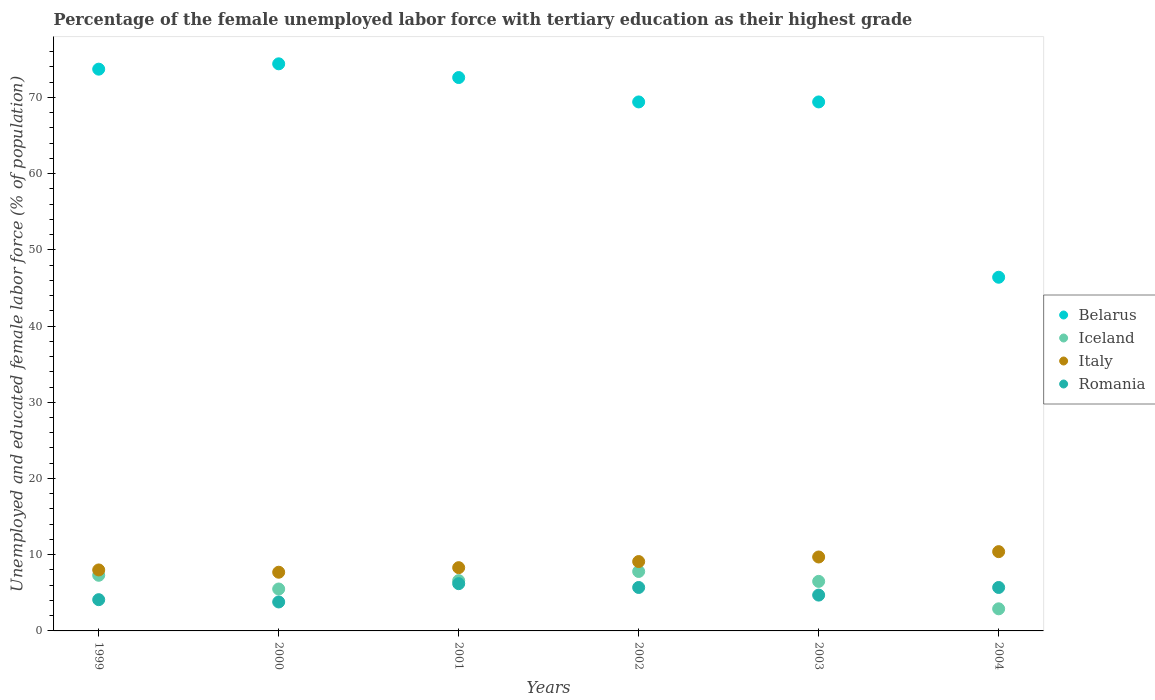Is the number of dotlines equal to the number of legend labels?
Offer a terse response. Yes. What is the percentage of the unemployed female labor force with tertiary education in Italy in 2004?
Provide a succinct answer. 10.4. Across all years, what is the maximum percentage of the unemployed female labor force with tertiary education in Iceland?
Offer a very short reply. 7.8. Across all years, what is the minimum percentage of the unemployed female labor force with tertiary education in Italy?
Your answer should be compact. 7.7. In which year was the percentage of the unemployed female labor force with tertiary education in Romania maximum?
Provide a short and direct response. 2001. What is the total percentage of the unemployed female labor force with tertiary education in Iceland in the graph?
Give a very brief answer. 36.6. What is the difference between the percentage of the unemployed female labor force with tertiary education in Italy in 1999 and that in 2003?
Offer a terse response. -1.7. What is the difference between the percentage of the unemployed female labor force with tertiary education in Romania in 2004 and the percentage of the unemployed female labor force with tertiary education in Belarus in 2002?
Provide a succinct answer. -63.7. What is the average percentage of the unemployed female labor force with tertiary education in Romania per year?
Give a very brief answer. 5.03. In the year 2004, what is the difference between the percentage of the unemployed female labor force with tertiary education in Belarus and percentage of the unemployed female labor force with tertiary education in Romania?
Your response must be concise. 40.7. In how many years, is the percentage of the unemployed female labor force with tertiary education in Italy greater than 2 %?
Offer a very short reply. 6. What is the ratio of the percentage of the unemployed female labor force with tertiary education in Belarus in 2001 to that in 2002?
Provide a succinct answer. 1.05. Is the percentage of the unemployed female labor force with tertiary education in Romania in 2002 less than that in 2004?
Provide a succinct answer. No. What is the difference between the highest and the second highest percentage of the unemployed female labor force with tertiary education in Belarus?
Provide a succinct answer. 0.7. What is the difference between the highest and the lowest percentage of the unemployed female labor force with tertiary education in Italy?
Make the answer very short. 2.7. Is it the case that in every year, the sum of the percentage of the unemployed female labor force with tertiary education in Italy and percentage of the unemployed female labor force with tertiary education in Belarus  is greater than the sum of percentage of the unemployed female labor force with tertiary education in Iceland and percentage of the unemployed female labor force with tertiary education in Romania?
Give a very brief answer. Yes. Is the percentage of the unemployed female labor force with tertiary education in Italy strictly greater than the percentage of the unemployed female labor force with tertiary education in Belarus over the years?
Your answer should be very brief. No. How many years are there in the graph?
Give a very brief answer. 6. Are the values on the major ticks of Y-axis written in scientific E-notation?
Keep it short and to the point. No. Does the graph contain any zero values?
Your answer should be very brief. No. Does the graph contain grids?
Ensure brevity in your answer.  No. What is the title of the graph?
Provide a succinct answer. Percentage of the female unemployed labor force with tertiary education as their highest grade. Does "Lithuania" appear as one of the legend labels in the graph?
Your answer should be very brief. No. What is the label or title of the Y-axis?
Ensure brevity in your answer.  Unemployed and educated female labor force (% of population). What is the Unemployed and educated female labor force (% of population) in Belarus in 1999?
Keep it short and to the point. 73.7. What is the Unemployed and educated female labor force (% of population) of Iceland in 1999?
Ensure brevity in your answer.  7.3. What is the Unemployed and educated female labor force (% of population) in Italy in 1999?
Provide a short and direct response. 8. What is the Unemployed and educated female labor force (% of population) of Romania in 1999?
Your response must be concise. 4.1. What is the Unemployed and educated female labor force (% of population) in Belarus in 2000?
Make the answer very short. 74.4. What is the Unemployed and educated female labor force (% of population) in Iceland in 2000?
Your answer should be very brief. 5.5. What is the Unemployed and educated female labor force (% of population) in Italy in 2000?
Ensure brevity in your answer.  7.7. What is the Unemployed and educated female labor force (% of population) in Romania in 2000?
Your answer should be compact. 3.8. What is the Unemployed and educated female labor force (% of population) in Belarus in 2001?
Offer a very short reply. 72.6. What is the Unemployed and educated female labor force (% of population) of Iceland in 2001?
Ensure brevity in your answer.  6.6. What is the Unemployed and educated female labor force (% of population) in Italy in 2001?
Offer a very short reply. 8.3. What is the Unemployed and educated female labor force (% of population) in Romania in 2001?
Your answer should be very brief. 6.2. What is the Unemployed and educated female labor force (% of population) in Belarus in 2002?
Provide a succinct answer. 69.4. What is the Unemployed and educated female labor force (% of population) in Iceland in 2002?
Provide a succinct answer. 7.8. What is the Unemployed and educated female labor force (% of population) of Italy in 2002?
Offer a very short reply. 9.1. What is the Unemployed and educated female labor force (% of population) of Romania in 2002?
Provide a succinct answer. 5.7. What is the Unemployed and educated female labor force (% of population) of Belarus in 2003?
Give a very brief answer. 69.4. What is the Unemployed and educated female labor force (% of population) in Italy in 2003?
Keep it short and to the point. 9.7. What is the Unemployed and educated female labor force (% of population) of Romania in 2003?
Offer a very short reply. 4.7. What is the Unemployed and educated female labor force (% of population) in Belarus in 2004?
Offer a terse response. 46.4. What is the Unemployed and educated female labor force (% of population) in Iceland in 2004?
Give a very brief answer. 2.9. What is the Unemployed and educated female labor force (% of population) in Italy in 2004?
Provide a short and direct response. 10.4. What is the Unemployed and educated female labor force (% of population) in Romania in 2004?
Your answer should be very brief. 5.7. Across all years, what is the maximum Unemployed and educated female labor force (% of population) in Belarus?
Keep it short and to the point. 74.4. Across all years, what is the maximum Unemployed and educated female labor force (% of population) in Iceland?
Your answer should be very brief. 7.8. Across all years, what is the maximum Unemployed and educated female labor force (% of population) in Italy?
Your response must be concise. 10.4. Across all years, what is the maximum Unemployed and educated female labor force (% of population) in Romania?
Make the answer very short. 6.2. Across all years, what is the minimum Unemployed and educated female labor force (% of population) of Belarus?
Your answer should be compact. 46.4. Across all years, what is the minimum Unemployed and educated female labor force (% of population) of Iceland?
Keep it short and to the point. 2.9. Across all years, what is the minimum Unemployed and educated female labor force (% of population) of Italy?
Your answer should be very brief. 7.7. Across all years, what is the minimum Unemployed and educated female labor force (% of population) of Romania?
Your answer should be compact. 3.8. What is the total Unemployed and educated female labor force (% of population) in Belarus in the graph?
Provide a short and direct response. 405.9. What is the total Unemployed and educated female labor force (% of population) of Iceland in the graph?
Ensure brevity in your answer.  36.6. What is the total Unemployed and educated female labor force (% of population) in Italy in the graph?
Provide a short and direct response. 53.2. What is the total Unemployed and educated female labor force (% of population) of Romania in the graph?
Offer a very short reply. 30.2. What is the difference between the Unemployed and educated female labor force (% of population) of Iceland in 1999 and that in 2000?
Offer a very short reply. 1.8. What is the difference between the Unemployed and educated female labor force (% of population) in Italy in 1999 and that in 2000?
Your response must be concise. 0.3. What is the difference between the Unemployed and educated female labor force (% of population) of Romania in 1999 and that in 2000?
Your response must be concise. 0.3. What is the difference between the Unemployed and educated female labor force (% of population) in Italy in 1999 and that in 2001?
Offer a very short reply. -0.3. What is the difference between the Unemployed and educated female labor force (% of population) of Romania in 1999 and that in 2001?
Your answer should be compact. -2.1. What is the difference between the Unemployed and educated female labor force (% of population) in Romania in 1999 and that in 2002?
Provide a short and direct response. -1.6. What is the difference between the Unemployed and educated female labor force (% of population) in Belarus in 1999 and that in 2003?
Offer a very short reply. 4.3. What is the difference between the Unemployed and educated female labor force (% of population) in Italy in 1999 and that in 2003?
Provide a succinct answer. -1.7. What is the difference between the Unemployed and educated female labor force (% of population) in Romania in 1999 and that in 2003?
Provide a succinct answer. -0.6. What is the difference between the Unemployed and educated female labor force (% of population) of Belarus in 1999 and that in 2004?
Make the answer very short. 27.3. What is the difference between the Unemployed and educated female labor force (% of population) in Iceland in 1999 and that in 2004?
Make the answer very short. 4.4. What is the difference between the Unemployed and educated female labor force (% of population) of Italy in 1999 and that in 2004?
Offer a terse response. -2.4. What is the difference between the Unemployed and educated female labor force (% of population) in Italy in 2000 and that in 2001?
Ensure brevity in your answer.  -0.6. What is the difference between the Unemployed and educated female labor force (% of population) of Iceland in 2000 and that in 2002?
Provide a succinct answer. -2.3. What is the difference between the Unemployed and educated female labor force (% of population) of Romania in 2000 and that in 2002?
Provide a succinct answer. -1.9. What is the difference between the Unemployed and educated female labor force (% of population) of Belarus in 2000 and that in 2003?
Provide a short and direct response. 5. What is the difference between the Unemployed and educated female labor force (% of population) of Romania in 2000 and that in 2003?
Offer a very short reply. -0.9. What is the difference between the Unemployed and educated female labor force (% of population) of Iceland in 2000 and that in 2004?
Provide a succinct answer. 2.6. What is the difference between the Unemployed and educated female labor force (% of population) in Italy in 2000 and that in 2004?
Your response must be concise. -2.7. What is the difference between the Unemployed and educated female labor force (% of population) in Romania in 2000 and that in 2004?
Offer a terse response. -1.9. What is the difference between the Unemployed and educated female labor force (% of population) of Belarus in 2001 and that in 2003?
Your response must be concise. 3.2. What is the difference between the Unemployed and educated female labor force (% of population) in Belarus in 2001 and that in 2004?
Offer a terse response. 26.2. What is the difference between the Unemployed and educated female labor force (% of population) in Iceland in 2001 and that in 2004?
Offer a very short reply. 3.7. What is the difference between the Unemployed and educated female labor force (% of population) of Romania in 2001 and that in 2004?
Make the answer very short. 0.5. What is the difference between the Unemployed and educated female labor force (% of population) in Belarus in 2002 and that in 2003?
Your response must be concise. 0. What is the difference between the Unemployed and educated female labor force (% of population) of Iceland in 2002 and that in 2003?
Make the answer very short. 1.3. What is the difference between the Unemployed and educated female labor force (% of population) in Italy in 2002 and that in 2004?
Your response must be concise. -1.3. What is the difference between the Unemployed and educated female labor force (% of population) in Romania in 2002 and that in 2004?
Provide a short and direct response. 0. What is the difference between the Unemployed and educated female labor force (% of population) of Romania in 2003 and that in 2004?
Provide a succinct answer. -1. What is the difference between the Unemployed and educated female labor force (% of population) in Belarus in 1999 and the Unemployed and educated female labor force (% of population) in Iceland in 2000?
Provide a succinct answer. 68.2. What is the difference between the Unemployed and educated female labor force (% of population) in Belarus in 1999 and the Unemployed and educated female labor force (% of population) in Romania in 2000?
Your response must be concise. 69.9. What is the difference between the Unemployed and educated female labor force (% of population) in Iceland in 1999 and the Unemployed and educated female labor force (% of population) in Italy in 2000?
Your response must be concise. -0.4. What is the difference between the Unemployed and educated female labor force (% of population) of Iceland in 1999 and the Unemployed and educated female labor force (% of population) of Romania in 2000?
Give a very brief answer. 3.5. What is the difference between the Unemployed and educated female labor force (% of population) in Belarus in 1999 and the Unemployed and educated female labor force (% of population) in Iceland in 2001?
Provide a succinct answer. 67.1. What is the difference between the Unemployed and educated female labor force (% of population) in Belarus in 1999 and the Unemployed and educated female labor force (% of population) in Italy in 2001?
Provide a succinct answer. 65.4. What is the difference between the Unemployed and educated female labor force (% of population) of Belarus in 1999 and the Unemployed and educated female labor force (% of population) of Romania in 2001?
Ensure brevity in your answer.  67.5. What is the difference between the Unemployed and educated female labor force (% of population) of Iceland in 1999 and the Unemployed and educated female labor force (% of population) of Italy in 2001?
Give a very brief answer. -1. What is the difference between the Unemployed and educated female labor force (% of population) of Iceland in 1999 and the Unemployed and educated female labor force (% of population) of Romania in 2001?
Give a very brief answer. 1.1. What is the difference between the Unemployed and educated female labor force (% of population) in Italy in 1999 and the Unemployed and educated female labor force (% of population) in Romania in 2001?
Your response must be concise. 1.8. What is the difference between the Unemployed and educated female labor force (% of population) in Belarus in 1999 and the Unemployed and educated female labor force (% of population) in Iceland in 2002?
Your answer should be very brief. 65.9. What is the difference between the Unemployed and educated female labor force (% of population) of Belarus in 1999 and the Unemployed and educated female labor force (% of population) of Italy in 2002?
Provide a succinct answer. 64.6. What is the difference between the Unemployed and educated female labor force (% of population) in Belarus in 1999 and the Unemployed and educated female labor force (% of population) in Romania in 2002?
Your response must be concise. 68. What is the difference between the Unemployed and educated female labor force (% of population) of Iceland in 1999 and the Unemployed and educated female labor force (% of population) of Italy in 2002?
Your answer should be compact. -1.8. What is the difference between the Unemployed and educated female labor force (% of population) of Iceland in 1999 and the Unemployed and educated female labor force (% of population) of Romania in 2002?
Provide a succinct answer. 1.6. What is the difference between the Unemployed and educated female labor force (% of population) of Belarus in 1999 and the Unemployed and educated female labor force (% of population) of Iceland in 2003?
Give a very brief answer. 67.2. What is the difference between the Unemployed and educated female labor force (% of population) in Belarus in 1999 and the Unemployed and educated female labor force (% of population) in Italy in 2003?
Make the answer very short. 64. What is the difference between the Unemployed and educated female labor force (% of population) of Belarus in 1999 and the Unemployed and educated female labor force (% of population) of Romania in 2003?
Ensure brevity in your answer.  69. What is the difference between the Unemployed and educated female labor force (% of population) of Iceland in 1999 and the Unemployed and educated female labor force (% of population) of Romania in 2003?
Provide a short and direct response. 2.6. What is the difference between the Unemployed and educated female labor force (% of population) in Italy in 1999 and the Unemployed and educated female labor force (% of population) in Romania in 2003?
Your answer should be very brief. 3.3. What is the difference between the Unemployed and educated female labor force (% of population) of Belarus in 1999 and the Unemployed and educated female labor force (% of population) of Iceland in 2004?
Offer a terse response. 70.8. What is the difference between the Unemployed and educated female labor force (% of population) of Belarus in 1999 and the Unemployed and educated female labor force (% of population) of Italy in 2004?
Your response must be concise. 63.3. What is the difference between the Unemployed and educated female labor force (% of population) in Iceland in 1999 and the Unemployed and educated female labor force (% of population) in Italy in 2004?
Your response must be concise. -3.1. What is the difference between the Unemployed and educated female labor force (% of population) of Italy in 1999 and the Unemployed and educated female labor force (% of population) of Romania in 2004?
Your response must be concise. 2.3. What is the difference between the Unemployed and educated female labor force (% of population) of Belarus in 2000 and the Unemployed and educated female labor force (% of population) of Iceland in 2001?
Your response must be concise. 67.8. What is the difference between the Unemployed and educated female labor force (% of population) in Belarus in 2000 and the Unemployed and educated female labor force (% of population) in Italy in 2001?
Ensure brevity in your answer.  66.1. What is the difference between the Unemployed and educated female labor force (% of population) of Belarus in 2000 and the Unemployed and educated female labor force (% of population) of Romania in 2001?
Provide a short and direct response. 68.2. What is the difference between the Unemployed and educated female labor force (% of population) of Iceland in 2000 and the Unemployed and educated female labor force (% of population) of Italy in 2001?
Offer a very short reply. -2.8. What is the difference between the Unemployed and educated female labor force (% of population) of Iceland in 2000 and the Unemployed and educated female labor force (% of population) of Romania in 2001?
Make the answer very short. -0.7. What is the difference between the Unemployed and educated female labor force (% of population) in Italy in 2000 and the Unemployed and educated female labor force (% of population) in Romania in 2001?
Provide a short and direct response. 1.5. What is the difference between the Unemployed and educated female labor force (% of population) in Belarus in 2000 and the Unemployed and educated female labor force (% of population) in Iceland in 2002?
Keep it short and to the point. 66.6. What is the difference between the Unemployed and educated female labor force (% of population) in Belarus in 2000 and the Unemployed and educated female labor force (% of population) in Italy in 2002?
Your answer should be compact. 65.3. What is the difference between the Unemployed and educated female labor force (% of population) in Belarus in 2000 and the Unemployed and educated female labor force (% of population) in Romania in 2002?
Offer a terse response. 68.7. What is the difference between the Unemployed and educated female labor force (% of population) in Belarus in 2000 and the Unemployed and educated female labor force (% of population) in Iceland in 2003?
Your answer should be very brief. 67.9. What is the difference between the Unemployed and educated female labor force (% of population) in Belarus in 2000 and the Unemployed and educated female labor force (% of population) in Italy in 2003?
Your answer should be very brief. 64.7. What is the difference between the Unemployed and educated female labor force (% of population) in Belarus in 2000 and the Unemployed and educated female labor force (% of population) in Romania in 2003?
Give a very brief answer. 69.7. What is the difference between the Unemployed and educated female labor force (% of population) of Iceland in 2000 and the Unemployed and educated female labor force (% of population) of Romania in 2003?
Ensure brevity in your answer.  0.8. What is the difference between the Unemployed and educated female labor force (% of population) in Belarus in 2000 and the Unemployed and educated female labor force (% of population) in Iceland in 2004?
Your answer should be compact. 71.5. What is the difference between the Unemployed and educated female labor force (% of population) of Belarus in 2000 and the Unemployed and educated female labor force (% of population) of Romania in 2004?
Your response must be concise. 68.7. What is the difference between the Unemployed and educated female labor force (% of population) of Iceland in 2000 and the Unemployed and educated female labor force (% of population) of Romania in 2004?
Provide a short and direct response. -0.2. What is the difference between the Unemployed and educated female labor force (% of population) of Belarus in 2001 and the Unemployed and educated female labor force (% of population) of Iceland in 2002?
Provide a succinct answer. 64.8. What is the difference between the Unemployed and educated female labor force (% of population) in Belarus in 2001 and the Unemployed and educated female labor force (% of population) in Italy in 2002?
Offer a very short reply. 63.5. What is the difference between the Unemployed and educated female labor force (% of population) in Belarus in 2001 and the Unemployed and educated female labor force (% of population) in Romania in 2002?
Make the answer very short. 66.9. What is the difference between the Unemployed and educated female labor force (% of population) in Iceland in 2001 and the Unemployed and educated female labor force (% of population) in Italy in 2002?
Your answer should be very brief. -2.5. What is the difference between the Unemployed and educated female labor force (% of population) of Iceland in 2001 and the Unemployed and educated female labor force (% of population) of Romania in 2002?
Your response must be concise. 0.9. What is the difference between the Unemployed and educated female labor force (% of population) in Italy in 2001 and the Unemployed and educated female labor force (% of population) in Romania in 2002?
Provide a short and direct response. 2.6. What is the difference between the Unemployed and educated female labor force (% of population) of Belarus in 2001 and the Unemployed and educated female labor force (% of population) of Iceland in 2003?
Give a very brief answer. 66.1. What is the difference between the Unemployed and educated female labor force (% of population) in Belarus in 2001 and the Unemployed and educated female labor force (% of population) in Italy in 2003?
Your answer should be very brief. 62.9. What is the difference between the Unemployed and educated female labor force (% of population) of Belarus in 2001 and the Unemployed and educated female labor force (% of population) of Romania in 2003?
Make the answer very short. 67.9. What is the difference between the Unemployed and educated female labor force (% of population) of Iceland in 2001 and the Unemployed and educated female labor force (% of population) of Romania in 2003?
Give a very brief answer. 1.9. What is the difference between the Unemployed and educated female labor force (% of population) of Belarus in 2001 and the Unemployed and educated female labor force (% of population) of Iceland in 2004?
Provide a succinct answer. 69.7. What is the difference between the Unemployed and educated female labor force (% of population) of Belarus in 2001 and the Unemployed and educated female labor force (% of population) of Italy in 2004?
Provide a succinct answer. 62.2. What is the difference between the Unemployed and educated female labor force (% of population) in Belarus in 2001 and the Unemployed and educated female labor force (% of population) in Romania in 2004?
Your answer should be very brief. 66.9. What is the difference between the Unemployed and educated female labor force (% of population) in Iceland in 2001 and the Unemployed and educated female labor force (% of population) in Italy in 2004?
Provide a short and direct response. -3.8. What is the difference between the Unemployed and educated female labor force (% of population) in Iceland in 2001 and the Unemployed and educated female labor force (% of population) in Romania in 2004?
Ensure brevity in your answer.  0.9. What is the difference between the Unemployed and educated female labor force (% of population) in Belarus in 2002 and the Unemployed and educated female labor force (% of population) in Iceland in 2003?
Give a very brief answer. 62.9. What is the difference between the Unemployed and educated female labor force (% of population) of Belarus in 2002 and the Unemployed and educated female labor force (% of population) of Italy in 2003?
Offer a terse response. 59.7. What is the difference between the Unemployed and educated female labor force (% of population) of Belarus in 2002 and the Unemployed and educated female labor force (% of population) of Romania in 2003?
Offer a very short reply. 64.7. What is the difference between the Unemployed and educated female labor force (% of population) of Iceland in 2002 and the Unemployed and educated female labor force (% of population) of Italy in 2003?
Your answer should be compact. -1.9. What is the difference between the Unemployed and educated female labor force (% of population) of Iceland in 2002 and the Unemployed and educated female labor force (% of population) of Romania in 2003?
Provide a short and direct response. 3.1. What is the difference between the Unemployed and educated female labor force (% of population) of Belarus in 2002 and the Unemployed and educated female labor force (% of population) of Iceland in 2004?
Your response must be concise. 66.5. What is the difference between the Unemployed and educated female labor force (% of population) in Belarus in 2002 and the Unemployed and educated female labor force (% of population) in Romania in 2004?
Offer a very short reply. 63.7. What is the difference between the Unemployed and educated female labor force (% of population) of Iceland in 2002 and the Unemployed and educated female labor force (% of population) of Italy in 2004?
Provide a short and direct response. -2.6. What is the difference between the Unemployed and educated female labor force (% of population) of Belarus in 2003 and the Unemployed and educated female labor force (% of population) of Iceland in 2004?
Your answer should be compact. 66.5. What is the difference between the Unemployed and educated female labor force (% of population) of Belarus in 2003 and the Unemployed and educated female labor force (% of population) of Italy in 2004?
Ensure brevity in your answer.  59. What is the difference between the Unemployed and educated female labor force (% of population) in Belarus in 2003 and the Unemployed and educated female labor force (% of population) in Romania in 2004?
Provide a short and direct response. 63.7. What is the difference between the Unemployed and educated female labor force (% of population) in Iceland in 2003 and the Unemployed and educated female labor force (% of population) in Italy in 2004?
Offer a terse response. -3.9. What is the difference between the Unemployed and educated female labor force (% of population) of Italy in 2003 and the Unemployed and educated female labor force (% of population) of Romania in 2004?
Your answer should be very brief. 4. What is the average Unemployed and educated female labor force (% of population) in Belarus per year?
Make the answer very short. 67.65. What is the average Unemployed and educated female labor force (% of population) of Italy per year?
Make the answer very short. 8.87. What is the average Unemployed and educated female labor force (% of population) in Romania per year?
Your response must be concise. 5.03. In the year 1999, what is the difference between the Unemployed and educated female labor force (% of population) of Belarus and Unemployed and educated female labor force (% of population) of Iceland?
Offer a terse response. 66.4. In the year 1999, what is the difference between the Unemployed and educated female labor force (% of population) in Belarus and Unemployed and educated female labor force (% of population) in Italy?
Keep it short and to the point. 65.7. In the year 1999, what is the difference between the Unemployed and educated female labor force (% of population) of Belarus and Unemployed and educated female labor force (% of population) of Romania?
Provide a short and direct response. 69.6. In the year 1999, what is the difference between the Unemployed and educated female labor force (% of population) of Iceland and Unemployed and educated female labor force (% of population) of Romania?
Offer a terse response. 3.2. In the year 2000, what is the difference between the Unemployed and educated female labor force (% of population) in Belarus and Unemployed and educated female labor force (% of population) in Iceland?
Make the answer very short. 68.9. In the year 2000, what is the difference between the Unemployed and educated female labor force (% of population) of Belarus and Unemployed and educated female labor force (% of population) of Italy?
Give a very brief answer. 66.7. In the year 2000, what is the difference between the Unemployed and educated female labor force (% of population) in Belarus and Unemployed and educated female labor force (% of population) in Romania?
Provide a succinct answer. 70.6. In the year 2000, what is the difference between the Unemployed and educated female labor force (% of population) of Iceland and Unemployed and educated female labor force (% of population) of Romania?
Your answer should be very brief. 1.7. In the year 2001, what is the difference between the Unemployed and educated female labor force (% of population) of Belarus and Unemployed and educated female labor force (% of population) of Italy?
Your response must be concise. 64.3. In the year 2001, what is the difference between the Unemployed and educated female labor force (% of population) of Belarus and Unemployed and educated female labor force (% of population) of Romania?
Your answer should be very brief. 66.4. In the year 2001, what is the difference between the Unemployed and educated female labor force (% of population) of Iceland and Unemployed and educated female labor force (% of population) of Romania?
Make the answer very short. 0.4. In the year 2002, what is the difference between the Unemployed and educated female labor force (% of population) in Belarus and Unemployed and educated female labor force (% of population) in Iceland?
Keep it short and to the point. 61.6. In the year 2002, what is the difference between the Unemployed and educated female labor force (% of population) in Belarus and Unemployed and educated female labor force (% of population) in Italy?
Offer a terse response. 60.3. In the year 2002, what is the difference between the Unemployed and educated female labor force (% of population) in Belarus and Unemployed and educated female labor force (% of population) in Romania?
Offer a terse response. 63.7. In the year 2002, what is the difference between the Unemployed and educated female labor force (% of population) of Iceland and Unemployed and educated female labor force (% of population) of Romania?
Ensure brevity in your answer.  2.1. In the year 2002, what is the difference between the Unemployed and educated female labor force (% of population) of Italy and Unemployed and educated female labor force (% of population) of Romania?
Your answer should be very brief. 3.4. In the year 2003, what is the difference between the Unemployed and educated female labor force (% of population) in Belarus and Unemployed and educated female labor force (% of population) in Iceland?
Provide a succinct answer. 62.9. In the year 2003, what is the difference between the Unemployed and educated female labor force (% of population) of Belarus and Unemployed and educated female labor force (% of population) of Italy?
Your response must be concise. 59.7. In the year 2003, what is the difference between the Unemployed and educated female labor force (% of population) in Belarus and Unemployed and educated female labor force (% of population) in Romania?
Ensure brevity in your answer.  64.7. In the year 2003, what is the difference between the Unemployed and educated female labor force (% of population) of Italy and Unemployed and educated female labor force (% of population) of Romania?
Give a very brief answer. 5. In the year 2004, what is the difference between the Unemployed and educated female labor force (% of population) of Belarus and Unemployed and educated female labor force (% of population) of Iceland?
Your answer should be compact. 43.5. In the year 2004, what is the difference between the Unemployed and educated female labor force (% of population) in Belarus and Unemployed and educated female labor force (% of population) in Romania?
Make the answer very short. 40.7. In the year 2004, what is the difference between the Unemployed and educated female labor force (% of population) of Iceland and Unemployed and educated female labor force (% of population) of Italy?
Give a very brief answer. -7.5. In the year 2004, what is the difference between the Unemployed and educated female labor force (% of population) in Iceland and Unemployed and educated female labor force (% of population) in Romania?
Ensure brevity in your answer.  -2.8. In the year 2004, what is the difference between the Unemployed and educated female labor force (% of population) of Italy and Unemployed and educated female labor force (% of population) of Romania?
Your answer should be very brief. 4.7. What is the ratio of the Unemployed and educated female labor force (% of population) in Belarus in 1999 to that in 2000?
Your answer should be very brief. 0.99. What is the ratio of the Unemployed and educated female labor force (% of population) in Iceland in 1999 to that in 2000?
Give a very brief answer. 1.33. What is the ratio of the Unemployed and educated female labor force (% of population) in Italy in 1999 to that in 2000?
Offer a very short reply. 1.04. What is the ratio of the Unemployed and educated female labor force (% of population) in Romania in 1999 to that in 2000?
Provide a succinct answer. 1.08. What is the ratio of the Unemployed and educated female labor force (% of population) of Belarus in 1999 to that in 2001?
Keep it short and to the point. 1.02. What is the ratio of the Unemployed and educated female labor force (% of population) in Iceland in 1999 to that in 2001?
Make the answer very short. 1.11. What is the ratio of the Unemployed and educated female labor force (% of population) in Italy in 1999 to that in 2001?
Provide a succinct answer. 0.96. What is the ratio of the Unemployed and educated female labor force (% of population) in Romania in 1999 to that in 2001?
Keep it short and to the point. 0.66. What is the ratio of the Unemployed and educated female labor force (% of population) in Belarus in 1999 to that in 2002?
Ensure brevity in your answer.  1.06. What is the ratio of the Unemployed and educated female labor force (% of population) in Iceland in 1999 to that in 2002?
Provide a short and direct response. 0.94. What is the ratio of the Unemployed and educated female labor force (% of population) in Italy in 1999 to that in 2002?
Provide a succinct answer. 0.88. What is the ratio of the Unemployed and educated female labor force (% of population) in Romania in 1999 to that in 2002?
Offer a very short reply. 0.72. What is the ratio of the Unemployed and educated female labor force (% of population) in Belarus in 1999 to that in 2003?
Give a very brief answer. 1.06. What is the ratio of the Unemployed and educated female labor force (% of population) of Iceland in 1999 to that in 2003?
Offer a very short reply. 1.12. What is the ratio of the Unemployed and educated female labor force (% of population) of Italy in 1999 to that in 2003?
Ensure brevity in your answer.  0.82. What is the ratio of the Unemployed and educated female labor force (% of population) of Romania in 1999 to that in 2003?
Keep it short and to the point. 0.87. What is the ratio of the Unemployed and educated female labor force (% of population) of Belarus in 1999 to that in 2004?
Offer a terse response. 1.59. What is the ratio of the Unemployed and educated female labor force (% of population) in Iceland in 1999 to that in 2004?
Make the answer very short. 2.52. What is the ratio of the Unemployed and educated female labor force (% of population) of Italy in 1999 to that in 2004?
Your answer should be compact. 0.77. What is the ratio of the Unemployed and educated female labor force (% of population) of Romania in 1999 to that in 2004?
Your answer should be compact. 0.72. What is the ratio of the Unemployed and educated female labor force (% of population) of Belarus in 2000 to that in 2001?
Keep it short and to the point. 1.02. What is the ratio of the Unemployed and educated female labor force (% of population) in Iceland in 2000 to that in 2001?
Provide a short and direct response. 0.83. What is the ratio of the Unemployed and educated female labor force (% of population) of Italy in 2000 to that in 2001?
Provide a succinct answer. 0.93. What is the ratio of the Unemployed and educated female labor force (% of population) in Romania in 2000 to that in 2001?
Give a very brief answer. 0.61. What is the ratio of the Unemployed and educated female labor force (% of population) of Belarus in 2000 to that in 2002?
Make the answer very short. 1.07. What is the ratio of the Unemployed and educated female labor force (% of population) in Iceland in 2000 to that in 2002?
Make the answer very short. 0.71. What is the ratio of the Unemployed and educated female labor force (% of population) in Italy in 2000 to that in 2002?
Offer a very short reply. 0.85. What is the ratio of the Unemployed and educated female labor force (% of population) in Belarus in 2000 to that in 2003?
Ensure brevity in your answer.  1.07. What is the ratio of the Unemployed and educated female labor force (% of population) in Iceland in 2000 to that in 2003?
Your response must be concise. 0.85. What is the ratio of the Unemployed and educated female labor force (% of population) of Italy in 2000 to that in 2003?
Your answer should be very brief. 0.79. What is the ratio of the Unemployed and educated female labor force (% of population) in Romania in 2000 to that in 2003?
Your answer should be compact. 0.81. What is the ratio of the Unemployed and educated female labor force (% of population) of Belarus in 2000 to that in 2004?
Make the answer very short. 1.6. What is the ratio of the Unemployed and educated female labor force (% of population) in Iceland in 2000 to that in 2004?
Your response must be concise. 1.9. What is the ratio of the Unemployed and educated female labor force (% of population) of Italy in 2000 to that in 2004?
Offer a very short reply. 0.74. What is the ratio of the Unemployed and educated female labor force (% of population) in Belarus in 2001 to that in 2002?
Give a very brief answer. 1.05. What is the ratio of the Unemployed and educated female labor force (% of population) in Iceland in 2001 to that in 2002?
Provide a short and direct response. 0.85. What is the ratio of the Unemployed and educated female labor force (% of population) in Italy in 2001 to that in 2002?
Your answer should be very brief. 0.91. What is the ratio of the Unemployed and educated female labor force (% of population) of Romania in 2001 to that in 2002?
Your response must be concise. 1.09. What is the ratio of the Unemployed and educated female labor force (% of population) of Belarus in 2001 to that in 2003?
Offer a terse response. 1.05. What is the ratio of the Unemployed and educated female labor force (% of population) of Iceland in 2001 to that in 2003?
Keep it short and to the point. 1.02. What is the ratio of the Unemployed and educated female labor force (% of population) in Italy in 2001 to that in 2003?
Provide a succinct answer. 0.86. What is the ratio of the Unemployed and educated female labor force (% of population) in Romania in 2001 to that in 2003?
Provide a short and direct response. 1.32. What is the ratio of the Unemployed and educated female labor force (% of population) of Belarus in 2001 to that in 2004?
Make the answer very short. 1.56. What is the ratio of the Unemployed and educated female labor force (% of population) in Iceland in 2001 to that in 2004?
Your answer should be very brief. 2.28. What is the ratio of the Unemployed and educated female labor force (% of population) of Italy in 2001 to that in 2004?
Ensure brevity in your answer.  0.8. What is the ratio of the Unemployed and educated female labor force (% of population) of Romania in 2001 to that in 2004?
Ensure brevity in your answer.  1.09. What is the ratio of the Unemployed and educated female labor force (% of population) of Iceland in 2002 to that in 2003?
Your response must be concise. 1.2. What is the ratio of the Unemployed and educated female labor force (% of population) of Italy in 2002 to that in 2003?
Provide a short and direct response. 0.94. What is the ratio of the Unemployed and educated female labor force (% of population) in Romania in 2002 to that in 2003?
Your answer should be compact. 1.21. What is the ratio of the Unemployed and educated female labor force (% of population) of Belarus in 2002 to that in 2004?
Make the answer very short. 1.5. What is the ratio of the Unemployed and educated female labor force (% of population) of Iceland in 2002 to that in 2004?
Offer a very short reply. 2.69. What is the ratio of the Unemployed and educated female labor force (% of population) of Romania in 2002 to that in 2004?
Your answer should be compact. 1. What is the ratio of the Unemployed and educated female labor force (% of population) in Belarus in 2003 to that in 2004?
Offer a very short reply. 1.5. What is the ratio of the Unemployed and educated female labor force (% of population) of Iceland in 2003 to that in 2004?
Offer a very short reply. 2.24. What is the ratio of the Unemployed and educated female labor force (% of population) in Italy in 2003 to that in 2004?
Your answer should be very brief. 0.93. What is the ratio of the Unemployed and educated female labor force (% of population) of Romania in 2003 to that in 2004?
Provide a short and direct response. 0.82. What is the difference between the highest and the second highest Unemployed and educated female labor force (% of population) of Belarus?
Keep it short and to the point. 0.7. 